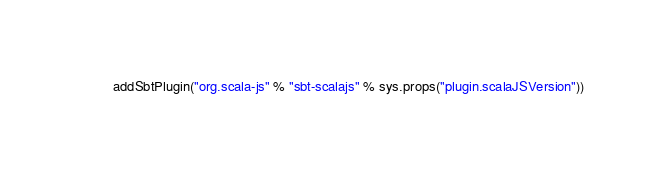<code> <loc_0><loc_0><loc_500><loc_500><_Scala_>addSbtPlugin("org.scala-js" % "sbt-scalajs" % sys.props("plugin.scalaJSVersion"))
</code> 